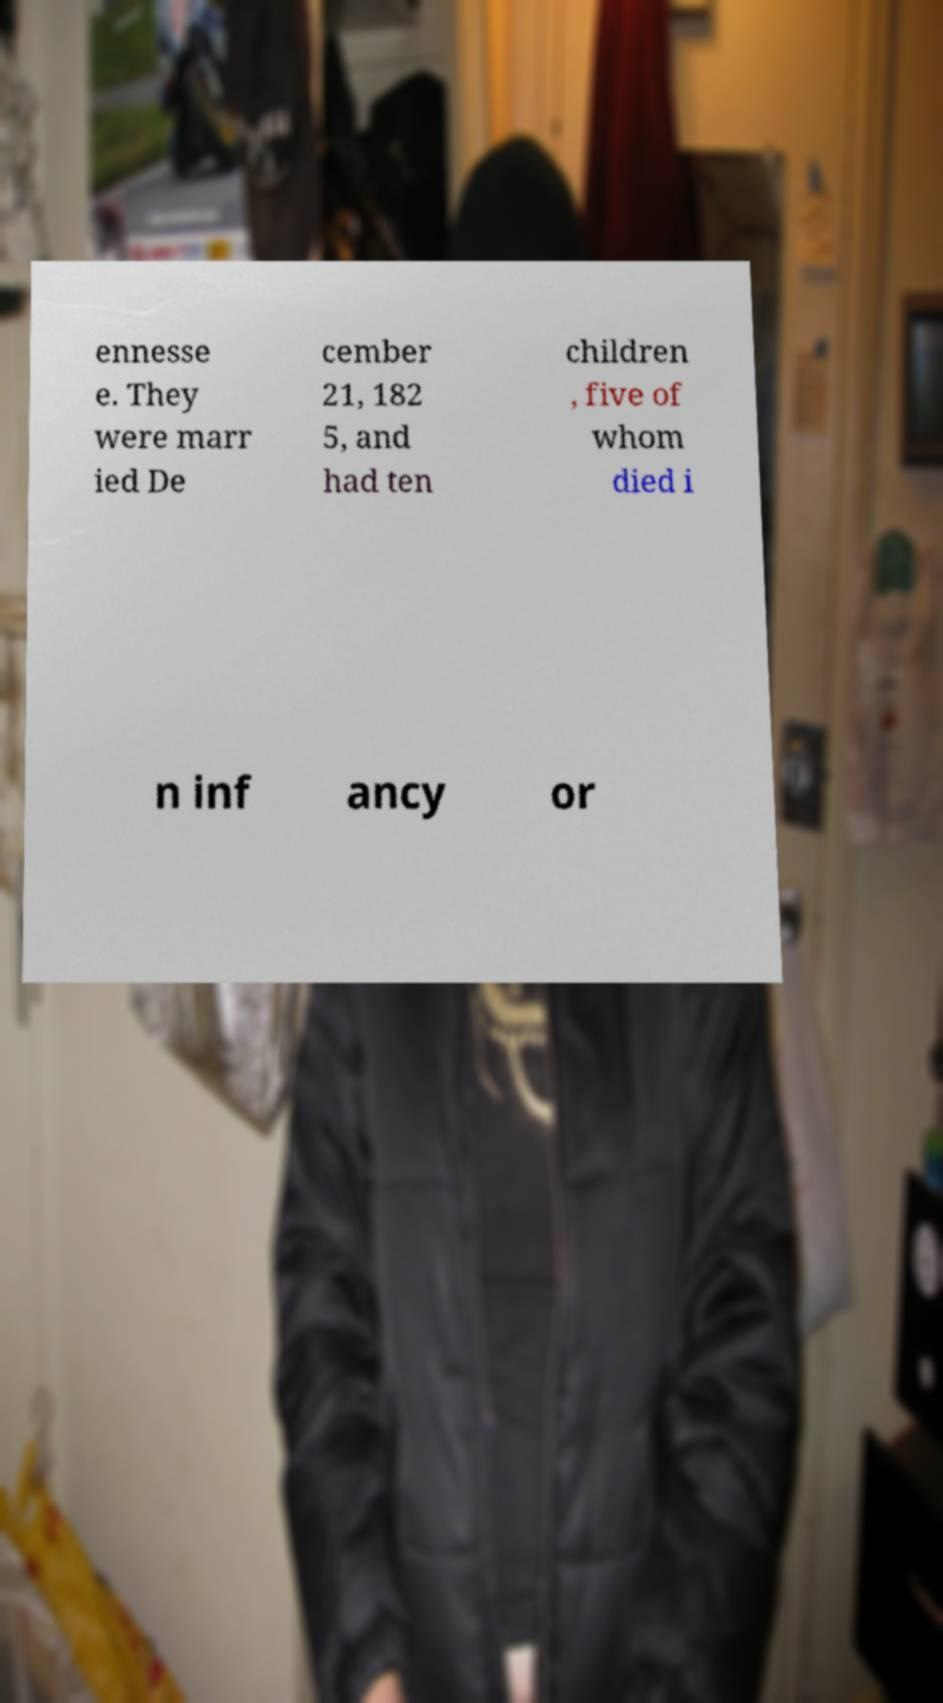I need the written content from this picture converted into text. Can you do that? ennesse e. They were marr ied De cember 21, 182 5, and had ten children , five of whom died i n inf ancy or 